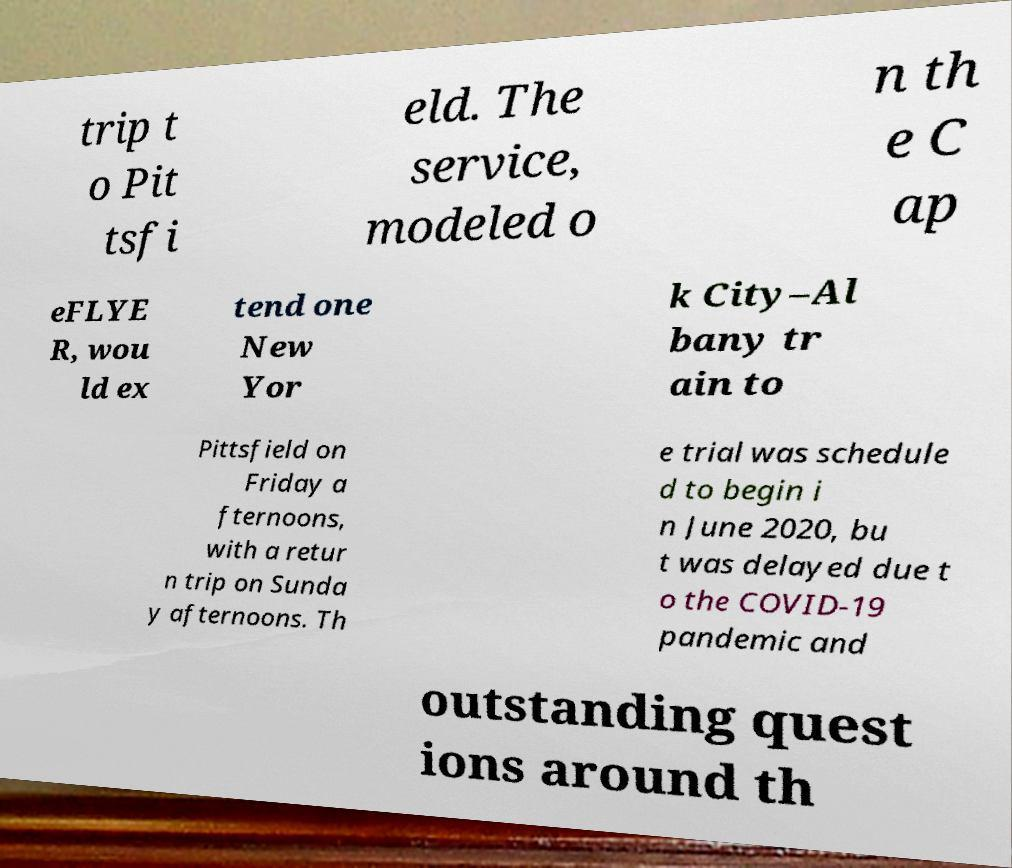Please read and relay the text visible in this image. What does it say? trip t o Pit tsfi eld. The service, modeled o n th e C ap eFLYE R, wou ld ex tend one New Yor k City–Al bany tr ain to Pittsfield on Friday a fternoons, with a retur n trip on Sunda y afternoons. Th e trial was schedule d to begin i n June 2020, bu t was delayed due t o the COVID-19 pandemic and outstanding quest ions around th 